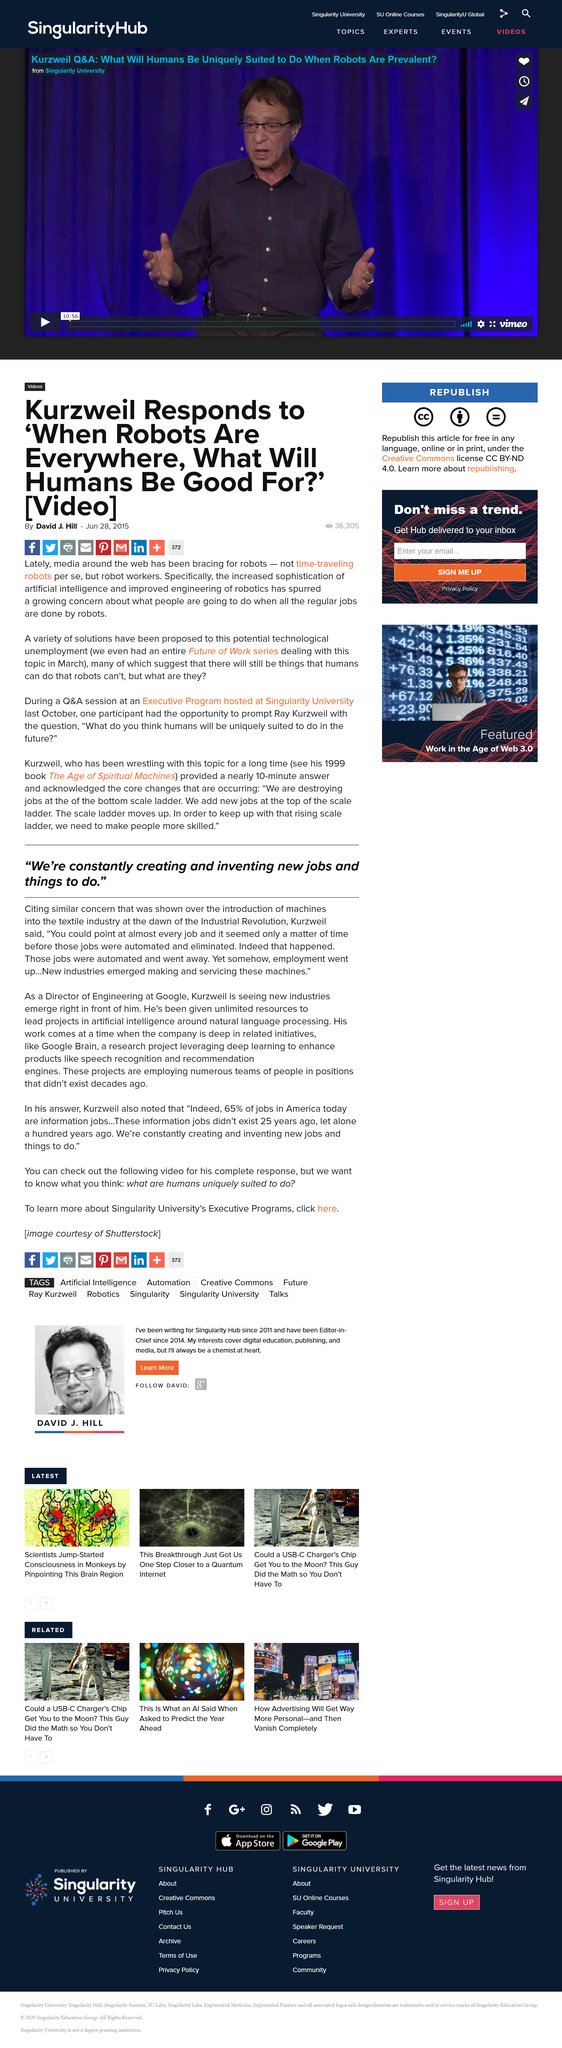Indicate a few pertinent items in this graphic. During the Industrial Revolution, jobs were automated and eliminated. Recently, there has been a heightened awareness and concern about the potential impact of robots on society, as media outlets have been reporting on the potential risks and benefits of advancements in this field. The textile industry expressed concern over the introduction of machines. During the Industrial Revolution, new jobs and industries were created, and their purpose was to manufacture and service machines. The article responding to Kurzweil was written by David J. Hill. 